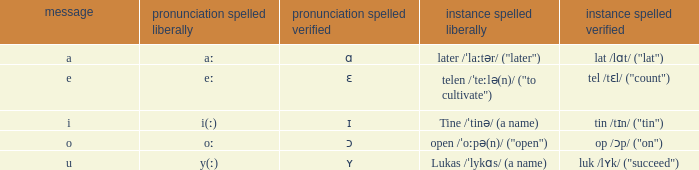What is Example Spelled Free, when Example Spelled Checked is "op /ɔp/ ("on")"? Open /ˈoːpə(n)/ ("open"). 